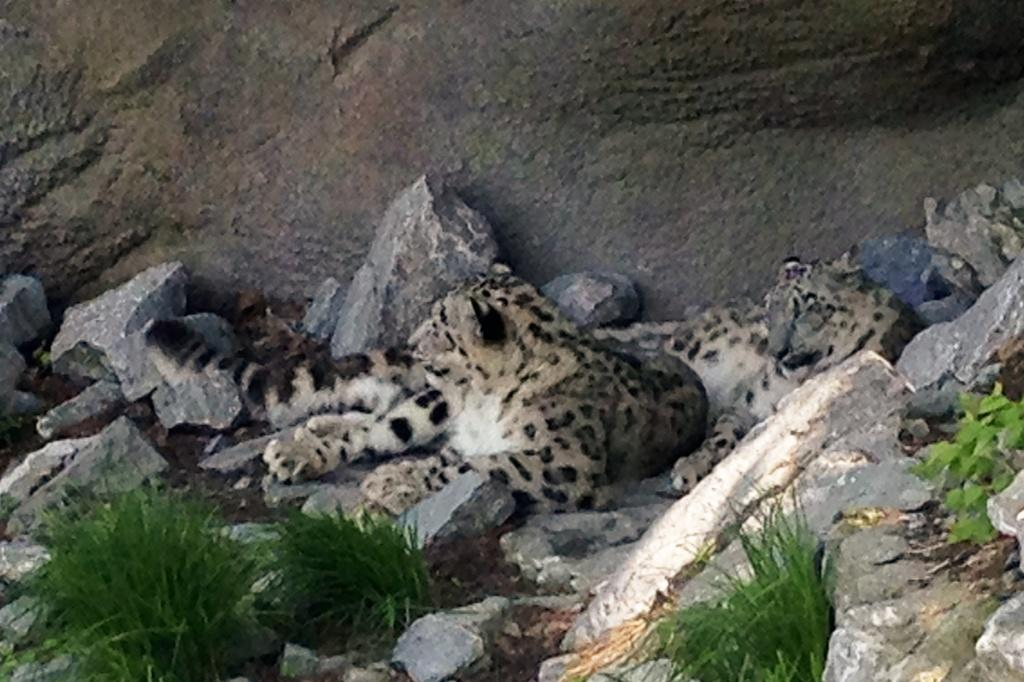What type of vegetation is visible in the front of the image? There is grass in the front of the image. What is located in the center of the image? There are animals in the center of the image. What can be seen in the background of the image? There is a wall in the background of the image. What is placed in front of the wall in the background? There are stones in front of the wall in the background. Where is the son of the geese in the image? There are no geese or their offspring present in the image. What place is depicted in the image? The image does not depict a specific place; it shows grass, animals, a wall, and stones. 